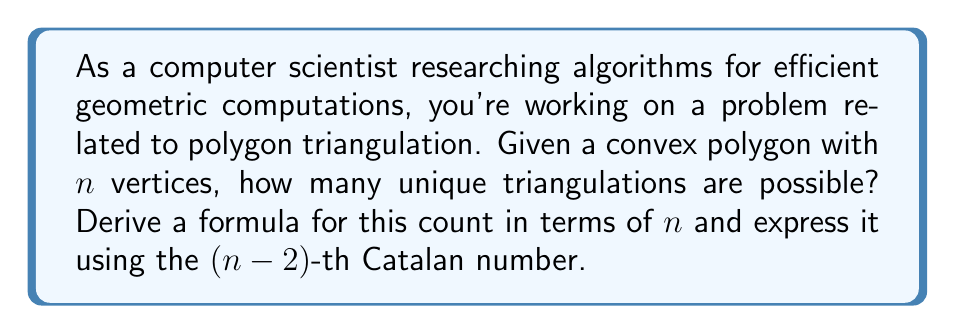What is the answer to this math problem? Let's approach this step-by-step:

1) First, recall that a triangulation of a convex polygon is a division of the polygon into triangles by drawing non-intersecting diagonals.

2) Let $T(n)$ be the number of unique triangulations for a convex polygon with $n$ vertices.

3) For $n = 3$, there's only one possible triangulation (the triangle itself). So, $T(3) = 1$.

4) For $n > 3$, we can choose any diagonal to start our triangulation. This diagonal will divide the polygon into two smaller polygons.

5) If we choose a diagonal from vertex 1 to vertex $k$ $(3 \leq k \leq n)$, we'll have:
   - A polygon with $k$ vertices (including the diagonal)
   - A polygon with $n-k+2$ vertices (including the diagonal)

6) The number of triangulations for this choice will be $T(k) \cdot T(n-k+2)$.

7) We need to sum this over all possible choices of $k$:

   $$T(n) = \sum_{k=3}^n T(k-1) \cdot T(n-k+1)$$

8) This recurrence relation is identical to the one for Catalan numbers, just shifted by 2.

9) The $n$-th Catalan number is given by:

   $$C_n = \frac{1}{n+1}\binom{2n}{n}$$

10) Therefore, the number of unique triangulations for a convex $n$-gon is equal to the $(n-2)$-th Catalan number:

    $$T(n) = C_{n-2} = \frac{1}{n-1}\binom{2n-4}{n-2}$$

11) This can also be written as:

    $$T(n) = \frac{(2n-4)!}{(n-1)!(n-2)!}$$

[asy]
size(200);
int n = 8;
pair[] vertices;
for(int i = 0; i < n; ++i) {
  vertices.push(100*dir(2*pi*i/n));
}
for(int i = 0; i < n; ++i) {
  dot(vertices[i]);
}
draw(polygon(vertices), blue);
draw(vertices[0]--vertices[3], red);
draw(vertices[0]--vertices[4], red);
draw(vertices[0]--vertices[5], red);
draw(vertices[0]--vertices[6], red);
draw(vertices[3]--vertices[5], red);
[/asy]
Answer: The number of unique triangulations for a convex polygon with $n$ vertices is given by the $(n-2)$-th Catalan number:

$$T(n) = C_{n-2} = \frac{1}{n-1}\binom{2n-4}{n-2} = \frac{(2n-4)!}{(n-1)!(n-2)!}$$ 